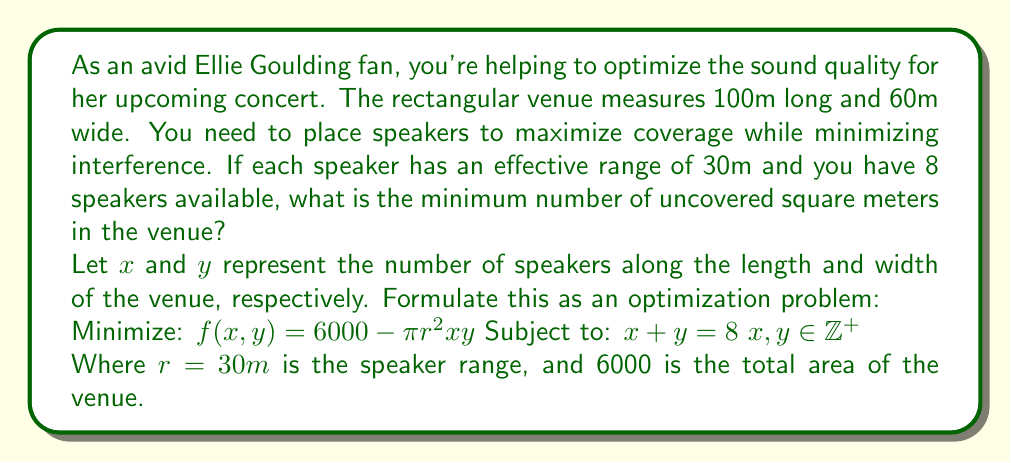What is the answer to this math problem? To solve this optimization problem, we'll follow these steps:

1) First, we need to understand what the objective function represents. $6000 - \pi r^2 xy$ calculates the uncovered area. We want to minimize this.

2) We have a constraint $x + y = 8$, which means $y = 8 - x$. We can substitute this into our objective function:

   $f(x) = 6000 - \pi (30)^2 x(8-x) = 6000 - 2827.43x(8-x)$

3) To find the minimum, we differentiate and set to zero:

   $\frac{df}{dx} = -2827.43(8-2x) = 0$
   $8-2x = 0$
   $x = 4$

4) This gives us a critical point at $x = 4$, which means $y = 4$ as well.

5) However, we need to check the integer values on either side (3 and 5) as well, since we're restricted to integer solutions:

   For $x = 3, y = 5$: $f(3) = 6000 - 2827.43 * 3 * 5 = 6000 - 42411.45 = -36411.45$
   For $x = 4, y = 4$: $f(4) = 6000 - 2827.43 * 4 * 4 = 6000 - 45238.88 = -39238.88$
   For $x = 5, y = 3$: $f(5) = 6000 - 2827.43 * 5 * 3 = 6000 - 42411.45 = -36411.45$

6) The minimum value occurs when $x = 4$ and $y = 4$.

7) To calculate the uncovered area:
   Total area: $100m * 60m = 6000m^2$
   Covered area: $8 * \pi (30m)^2 = 22619.47m^2$
   Uncovered area: $6000 - 22619.47 = -16619.47m^2$

8) Since we can't have negative area, this means the entire venue is covered with some overlap. The minimum uncovered area is thus 0m^2.
Answer: The minimum uncovered area is 0 square meters. 